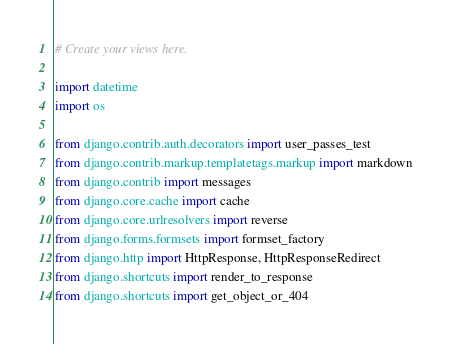Convert code to text. <code><loc_0><loc_0><loc_500><loc_500><_Python_># Create your views here.

import datetime
import os

from django.contrib.auth.decorators import user_passes_test
from django.contrib.markup.templatetags.markup import markdown
from django.contrib import messages
from django.core.cache import cache 
from django.core.urlresolvers import reverse
from django.forms.formsets import formset_factory
from django.http import HttpResponse, HttpResponseRedirect
from django.shortcuts import render_to_response
from django.shortcuts import get_object_or_404</code> 